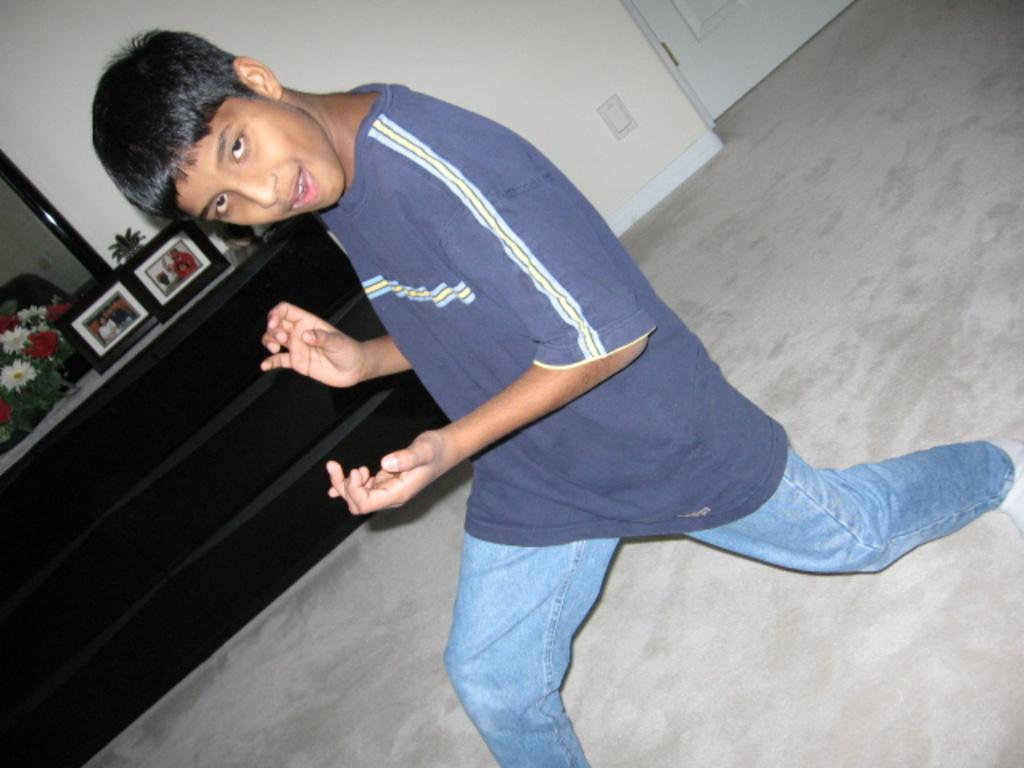Could you give a brief overview of what you see in this image? In this picture we can see a boy on the ground. There are frames, flowers, mirror, wall and a door is visible in the background. 